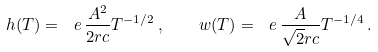Convert formula to latex. <formula><loc_0><loc_0><loc_500><loc_500>h ( T ) = \ e \, \frac { A ^ { 2 } } { 2 r c } T ^ { - 1 / 2 } \, , \quad w ( T ) = \ e \, \frac { A } { \sqrt { 2 } r c } T ^ { - 1 / 4 } \, .</formula> 